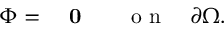<formula> <loc_0><loc_0><loc_500><loc_500>\begin{array} { r l } { \Phi = } & 0 \quad o n \quad \partial \Omega . } \end{array}</formula> 